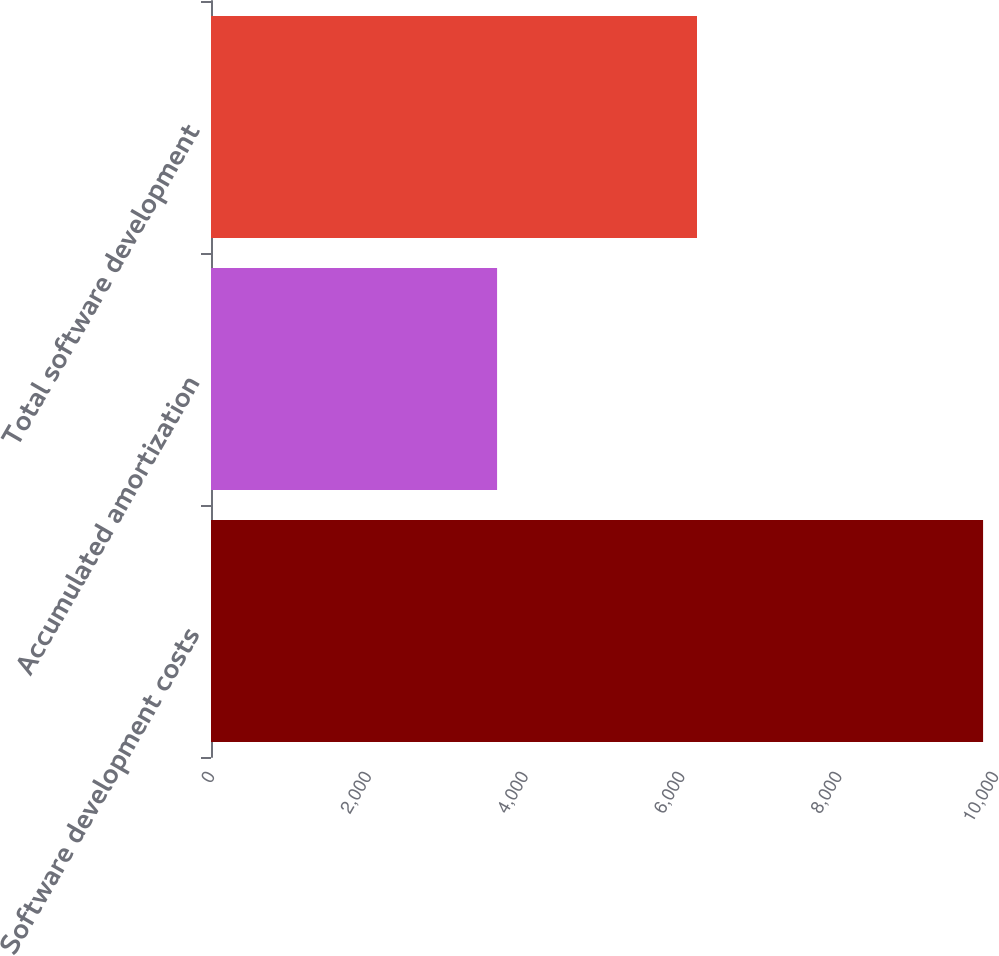<chart> <loc_0><loc_0><loc_500><loc_500><bar_chart><fcel>Software development costs<fcel>Accumulated amortization<fcel>Total software development<nl><fcel>9848<fcel>3649<fcel>6199<nl></chart> 